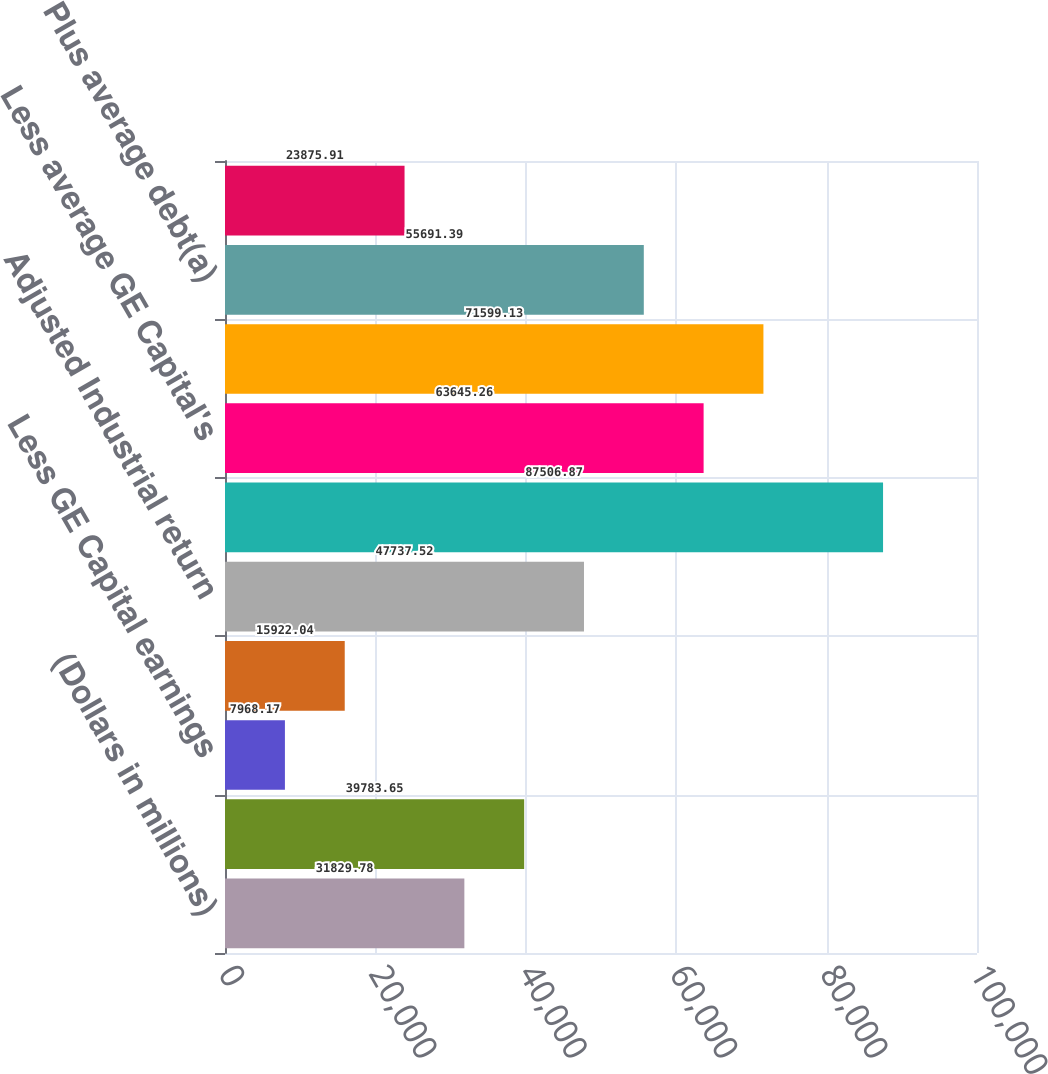<chart> <loc_0><loc_0><loc_500><loc_500><bar_chart><fcel>(Dollars in millions)<fcel>Earnings from continuing<fcel>Less GE Capital earnings<fcel>Plus GE after-tax interest<fcel>Adjusted Industrial return<fcel>Average GE shareholders'<fcel>Less average GE Capital's<fcel>Average Industrial<fcel>Plus average debt(a)<fcel>Plus other net(b)<nl><fcel>31829.8<fcel>39783.7<fcel>7968.17<fcel>15922<fcel>47737.5<fcel>87506.9<fcel>63645.3<fcel>71599.1<fcel>55691.4<fcel>23875.9<nl></chart> 